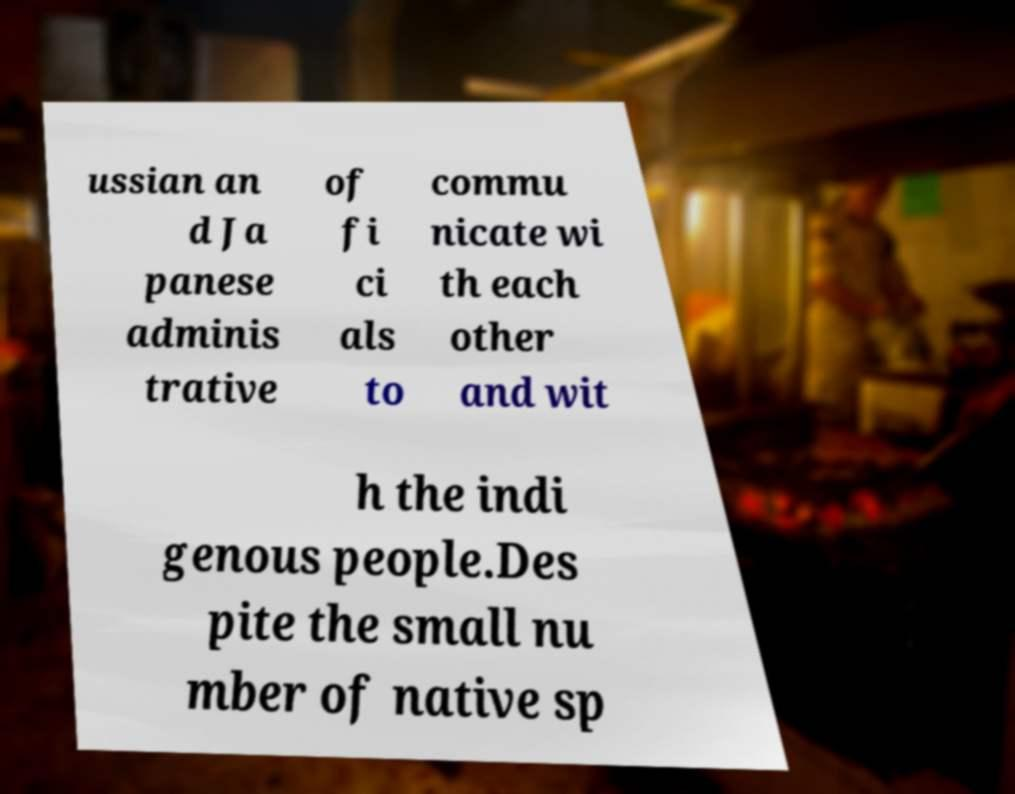Please identify and transcribe the text found in this image. ussian an d Ja panese adminis trative of fi ci als to commu nicate wi th each other and wit h the indi genous people.Des pite the small nu mber of native sp 